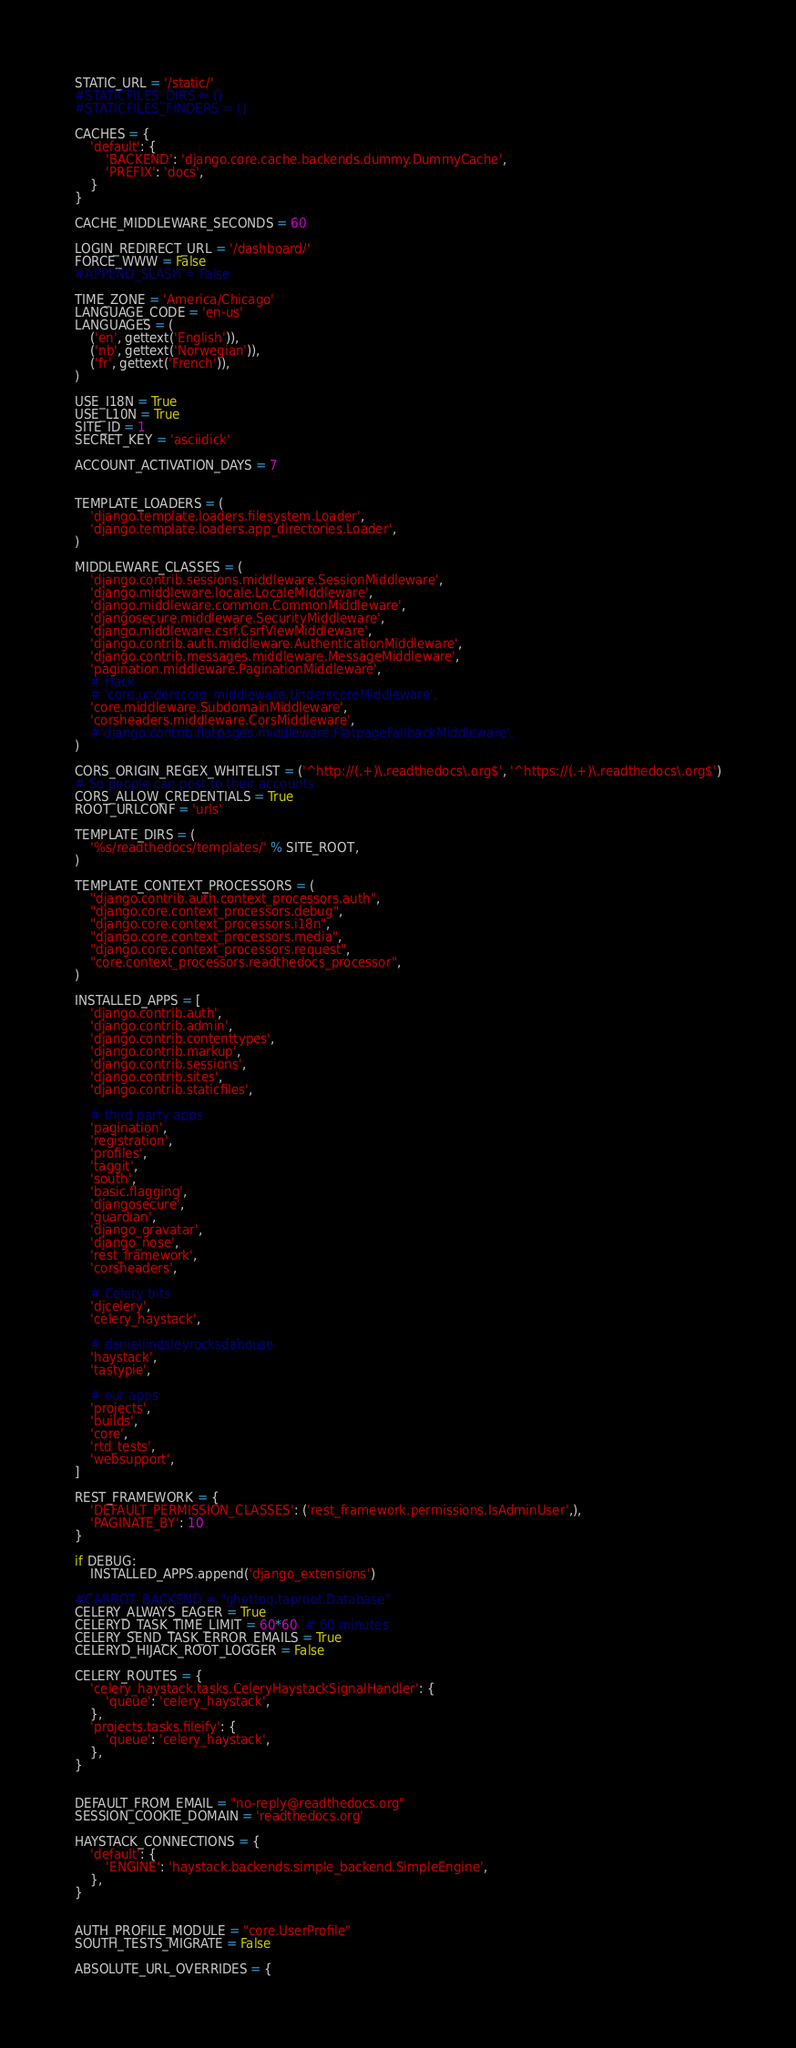<code> <loc_0><loc_0><loc_500><loc_500><_Python_>STATIC_URL = '/static/'
#STATICFILES_DIRS = ()
#STATICFILES_FINDERS = ()

CACHES = {
    'default': {
        'BACKEND': 'django.core.cache.backends.dummy.DummyCache',
        'PREFIX': 'docs',
    }
}

CACHE_MIDDLEWARE_SECONDS = 60

LOGIN_REDIRECT_URL = '/dashboard/'
FORCE_WWW = False
#APPEND_SLASH = False

TIME_ZONE = 'America/Chicago'
LANGUAGE_CODE = 'en-us'
LANGUAGES = (
    ('en', gettext('English')),
    ('nb', gettext('Norwegian')),
    ('fr', gettext('French')),
)

USE_I18N = True
USE_L10N = True
SITE_ID = 1
SECRET_KEY = 'asciidick'

ACCOUNT_ACTIVATION_DAYS = 7


TEMPLATE_LOADERS = (
    'django.template.loaders.filesystem.Loader',
    'django.template.loaders.app_directories.Loader',
)

MIDDLEWARE_CLASSES = (
    'django.contrib.sessions.middleware.SessionMiddleware',
    'django.middleware.locale.LocaleMiddleware',
    'django.middleware.common.CommonMiddleware',
    'djangosecure.middleware.SecurityMiddleware',
    'django.middleware.csrf.CsrfViewMiddleware',
    'django.contrib.auth.middleware.AuthenticationMiddleware',
    'django.contrib.messages.middleware.MessageMiddleware',
    'pagination.middleware.PaginationMiddleware',
    # Hack
    # 'core.underscore_middleware.UnderscoreMiddleware',
    'core.middleware.SubdomainMiddleware',
    'corsheaders.middleware.CorsMiddleware',
    #'django.contrib.flatpages.middleware.FlatpageFallbackMiddleware',
)

CORS_ORIGIN_REGEX_WHITELIST = ('^http://(.+)\.readthedocs\.org$', '^https://(.+)\.readthedocs\.org$')
# So people can post to their accounts
CORS_ALLOW_CREDENTIALS = True
ROOT_URLCONF = 'urls'

TEMPLATE_DIRS = (
    '%s/readthedocs/templates/' % SITE_ROOT,
)

TEMPLATE_CONTEXT_PROCESSORS = (
    "django.contrib.auth.context_processors.auth",
    "django.core.context_processors.debug",
    "django.core.context_processors.i18n",
    "django.core.context_processors.media",
    "django.core.context_processors.request",
    "core.context_processors.readthedocs_processor",
)

INSTALLED_APPS = [
    'django.contrib.auth',
    'django.contrib.admin',
    'django.contrib.contenttypes',
    'django.contrib.markup',
    'django.contrib.sessions',
    'django.contrib.sites',
    'django.contrib.staticfiles',

    # third party apps
    'pagination',
    'registration',
    'profiles',
    'taggit',
    'south',
    'basic.flagging',
    'djangosecure',
    'guardian',
    'django_gravatar',
    'django_nose',
    'rest_framework',
    'corsheaders',

    # Celery bits
    'djcelery',
    'celery_haystack',

    # daniellindsleyrocksdahouse
    'haystack',
    'tastypie',

    # our apps
    'projects',
    'builds',
    'core',
    'rtd_tests',
    'websupport',
]

REST_FRAMEWORK = {
    'DEFAULT_PERMISSION_CLASSES': ('rest_framework.permissions.IsAdminUser',),
    'PAGINATE_BY': 10
}

if DEBUG:
    INSTALLED_APPS.append('django_extensions')

#CARROT_BACKEND = "ghettoq.taproot.Database"
CELERY_ALWAYS_EAGER = True
CELERYD_TASK_TIME_LIMIT = 60*60  # 60 minutes
CELERY_SEND_TASK_ERROR_EMAILS = True
CELERYD_HIJACK_ROOT_LOGGER = False

CELERY_ROUTES = {
    'celery_haystack.tasks.CeleryHaystackSignalHandler': {
        'queue': 'celery_haystack',
    },
    'projects.tasks.fileify': {
        'queue': 'celery_haystack',
    },
}


DEFAULT_FROM_EMAIL = "no-reply@readthedocs.org"
SESSION_COOKIE_DOMAIN = 'readthedocs.org'

HAYSTACK_CONNECTIONS = {
    'default': {
        'ENGINE': 'haystack.backends.simple_backend.SimpleEngine',
    },
}


AUTH_PROFILE_MODULE = "core.UserProfile"
SOUTH_TESTS_MIGRATE = False

ABSOLUTE_URL_OVERRIDES = {</code> 